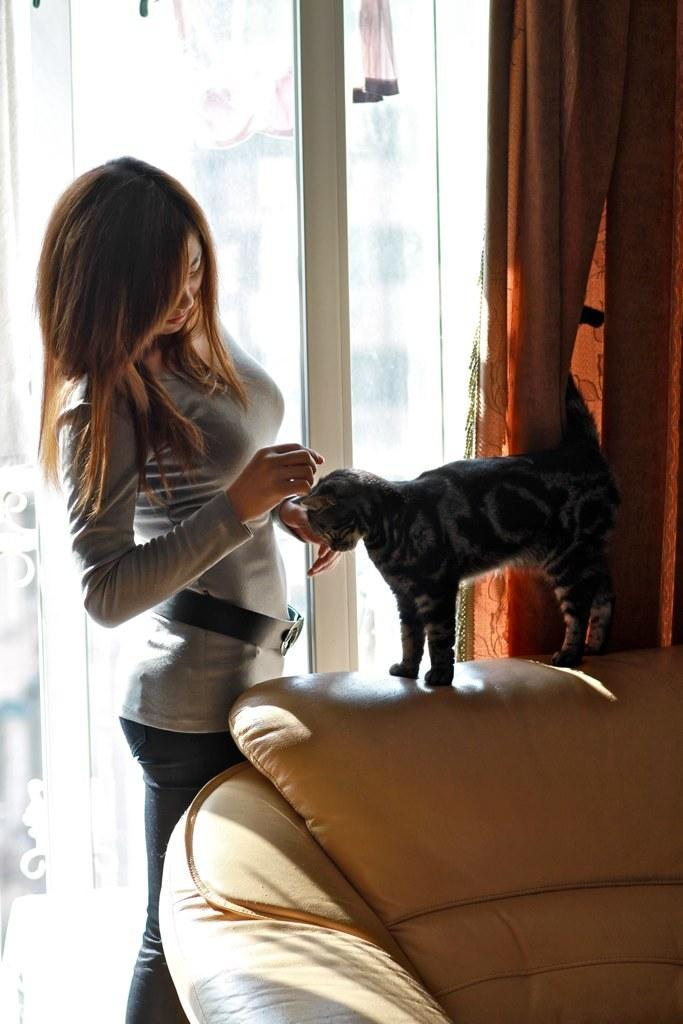Who is present in the image? There is a woman in the image. What animal is also present in the image? There is a cat in the image. Where is the cat located in relation to the woman? The cat is near the woman. What is the cat sitting on? The cat is on a couch. What can be seen in the background of the image? There is a window in the background of the image. Is there any window treatment present in the image? Yes, there is a curtain associated with the window. How many wrens are perched on the curtain in the image? There are no wrens present in the image; only a woman, a cat, and a curtain are visible. Is there any evidence of a cobweb in the image? There is no mention of a cobweb in the provided facts, and therefore it cannot be determined if one is present in the image. 